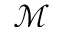Convert formula to latex. <formula><loc_0><loc_0><loc_500><loc_500>\mathcal { M }</formula> 